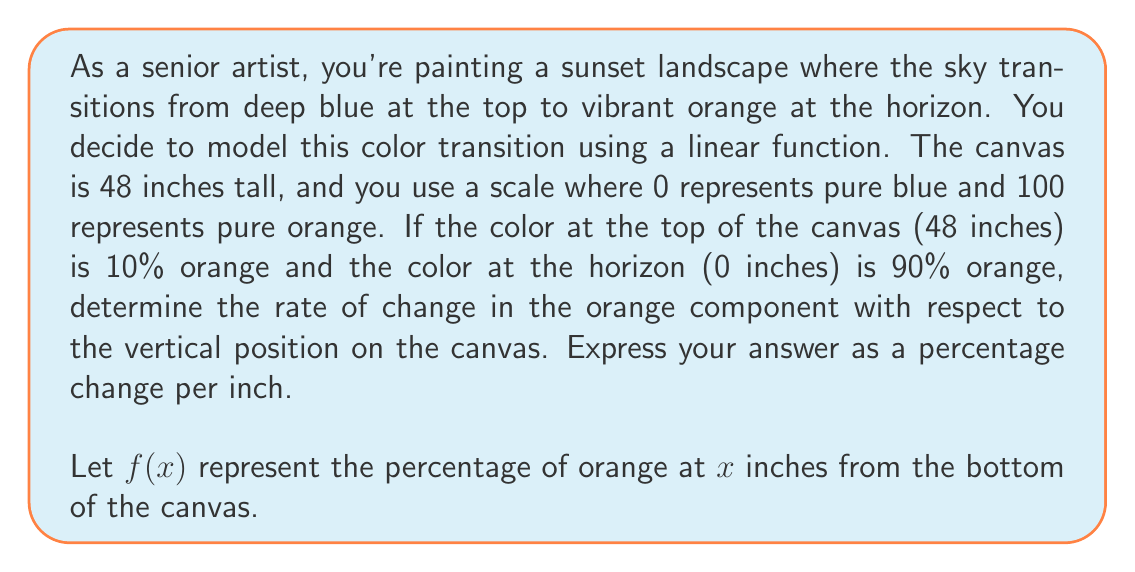Can you answer this question? To solve this problem, we need to find the slope of the linear function representing the color gradient. Let's approach this step-by-step:

1) We know two points on this linear function:
   At $x = 0$ (horizon), $f(0) = 90$
   At $x = 48$ (top), $f(48) = 10$

2) The general form of a linear function is $f(x) = mx + b$, where $m$ is the slope (rate of change) and $b$ is the y-intercept.

3) To find the slope, we can use the point-slope formula:

   $$m = \frac{y_2 - y_1}{x_2 - x_1} = \frac{f(48) - f(0)}{48 - 0}$$

4) Substituting the values:

   $$m = \frac{10 - 90}{48 - 0} = \frac{-80}{48}$$

5) Simplifying:

   $$m = -\frac{5}{3} \approx -1.67$$

6) The slope represents the change in the percentage of orange per inch. Since we're moving from bottom to top, a negative slope indicates a decrease in the orange component as we move up the canvas.

7) To express this as a percentage change per inch, we multiply by 100:

   $$\text{Rate of change} = -\frac{5}{3} \times 100 = -\frac{500}{3} \% \text{ per inch}$$

This means for every inch we move up the canvas, the orange component decreases by approximately 1.67%.
Answer: The rate of change in the orange component is $-\frac{500}{3} \%$ per inch, or approximately $-1.67 \%$ per inch. 